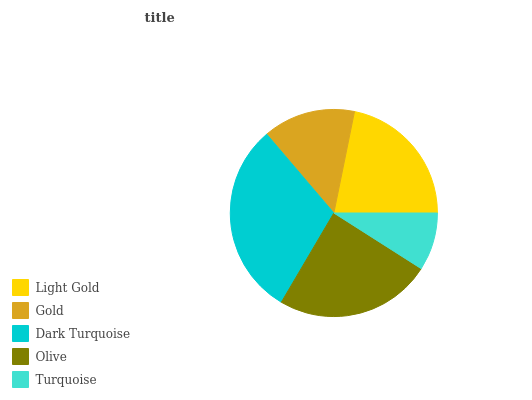Is Turquoise the minimum?
Answer yes or no. Yes. Is Dark Turquoise the maximum?
Answer yes or no. Yes. Is Gold the minimum?
Answer yes or no. No. Is Gold the maximum?
Answer yes or no. No. Is Light Gold greater than Gold?
Answer yes or no. Yes. Is Gold less than Light Gold?
Answer yes or no. Yes. Is Gold greater than Light Gold?
Answer yes or no. No. Is Light Gold less than Gold?
Answer yes or no. No. Is Light Gold the high median?
Answer yes or no. Yes. Is Light Gold the low median?
Answer yes or no. Yes. Is Turquoise the high median?
Answer yes or no. No. Is Olive the low median?
Answer yes or no. No. 